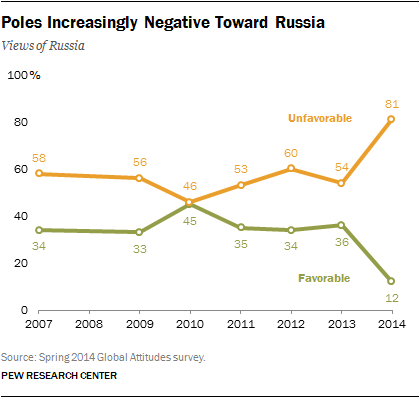Draw attention to some important aspects in this diagram. There are 2 values of the green graph that are equal to 34. The value of Favorable graph 36 in 2013 was favorable. 